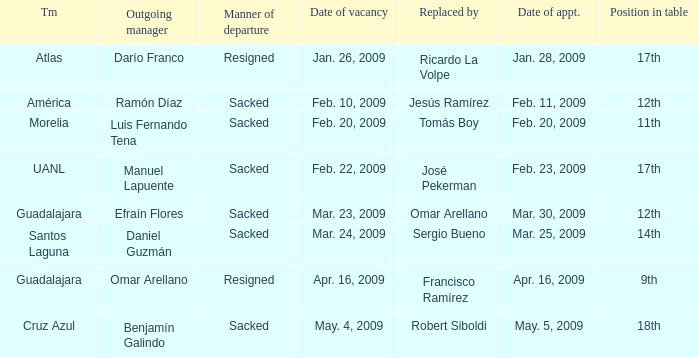What is Team, when Replaced By is "Omar Arellano"? Guadalajara. 